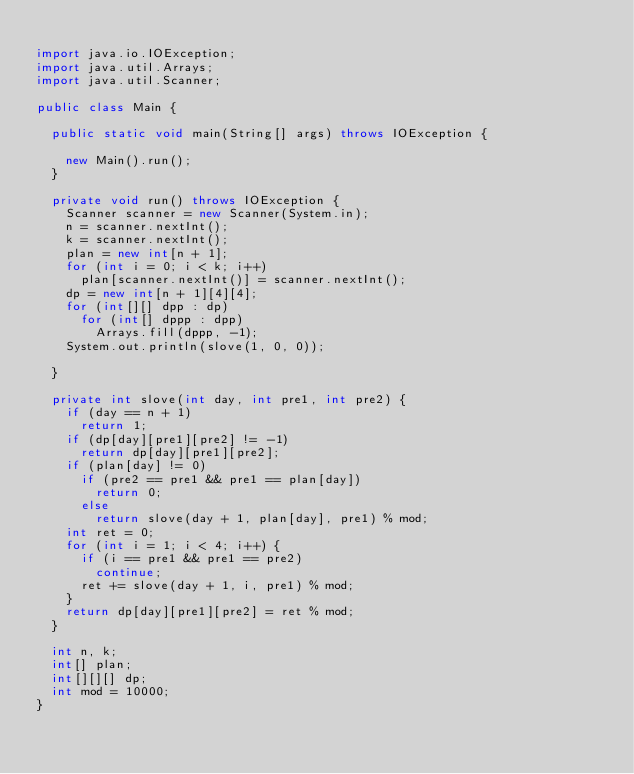<code> <loc_0><loc_0><loc_500><loc_500><_Java_>
import java.io.IOException;
import java.util.Arrays;
import java.util.Scanner;

public class Main {

	public static void main(String[] args) throws IOException {

		new Main().run();
	}

	private void run() throws IOException {
		Scanner scanner = new Scanner(System.in);
		n = scanner.nextInt();
		k = scanner.nextInt();
		plan = new int[n + 1];
		for (int i = 0; i < k; i++)
			plan[scanner.nextInt()] = scanner.nextInt();
		dp = new int[n + 1][4][4];
		for (int[][] dpp : dp)
			for (int[] dppp : dpp)
				Arrays.fill(dppp, -1);
		System.out.println(slove(1, 0, 0));

	}

	private int slove(int day, int pre1, int pre2) {
		if (day == n + 1)
			return 1;
		if (dp[day][pre1][pre2] != -1)
			return dp[day][pre1][pre2];
		if (plan[day] != 0)
			if (pre2 == pre1 && pre1 == plan[day])
				return 0;
			else
				return slove(day + 1, plan[day], pre1) % mod;
		int ret = 0;
		for (int i = 1; i < 4; i++) {
			if (i == pre1 && pre1 == pre2)
				continue;
			ret += slove(day + 1, i, pre1) % mod;
		}
		return dp[day][pre1][pre2] = ret % mod;
	}

	int n, k;
	int[] plan;
	int[][][] dp;
	int mod = 10000;
}</code> 